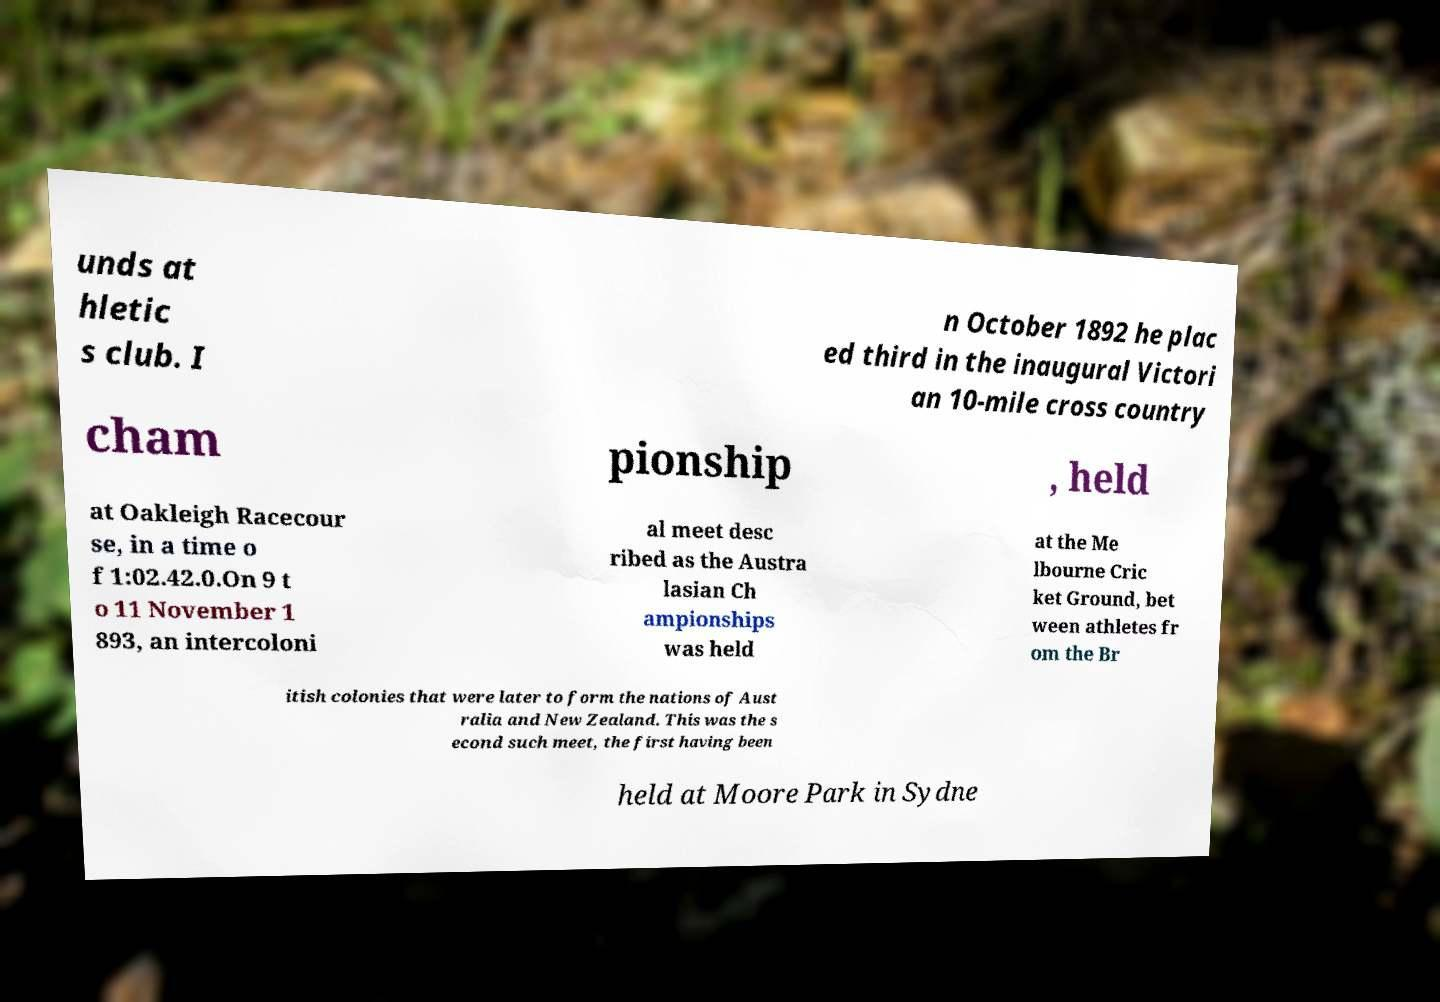Please read and relay the text visible in this image. What does it say? unds at hletic s club. I n October 1892 he plac ed third in the inaugural Victori an 10-mile cross country cham pionship , held at Oakleigh Racecour se, in a time o f 1:02.42.0.On 9 t o 11 November 1 893, an intercoloni al meet desc ribed as the Austra lasian Ch ampionships was held at the Me lbourne Cric ket Ground, bet ween athletes fr om the Br itish colonies that were later to form the nations of Aust ralia and New Zealand. This was the s econd such meet, the first having been held at Moore Park in Sydne 